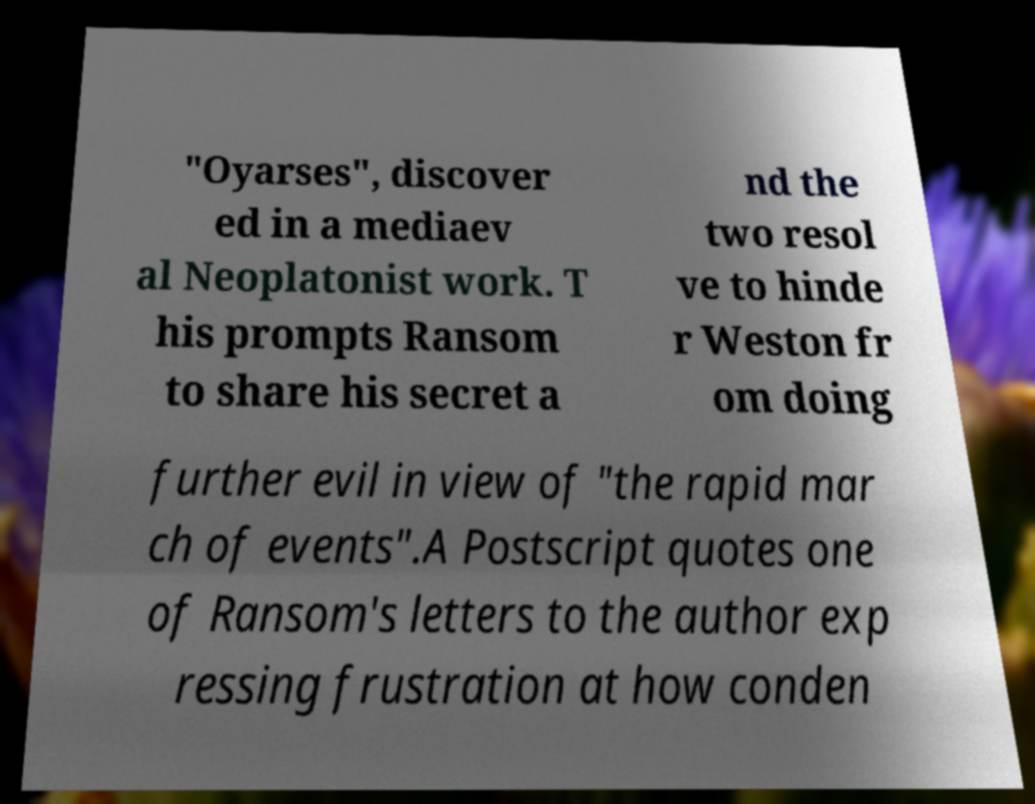Please identify and transcribe the text found in this image. "Oyarses", discover ed in a mediaev al Neoplatonist work. T his prompts Ransom to share his secret a nd the two resol ve to hinde r Weston fr om doing further evil in view of "the rapid mar ch of events".A Postscript quotes one of Ransom's letters to the author exp ressing frustration at how conden 